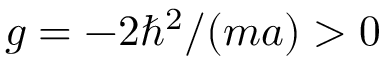Convert formula to latex. <formula><loc_0><loc_0><loc_500><loc_500>g = - 2 \hbar { ^ } { 2 } / ( m a ) > 0</formula> 